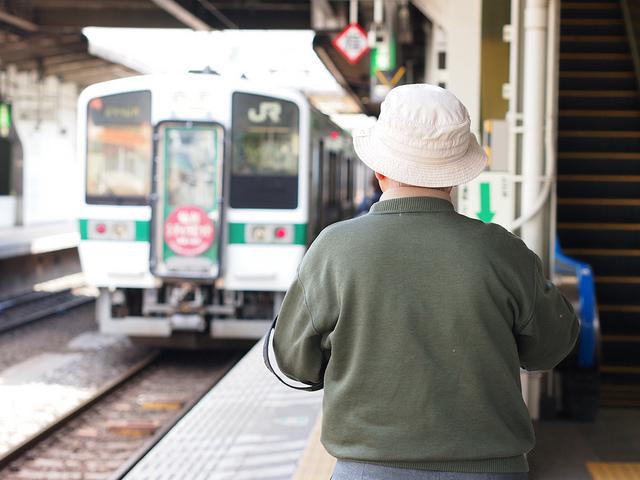What color is the sign at the back of the train?
Quick response, please. Red. What is the style of the white hat called?
Answer briefly. Fisherman. Is this man waiting for a bus?
Write a very short answer. Yes. 